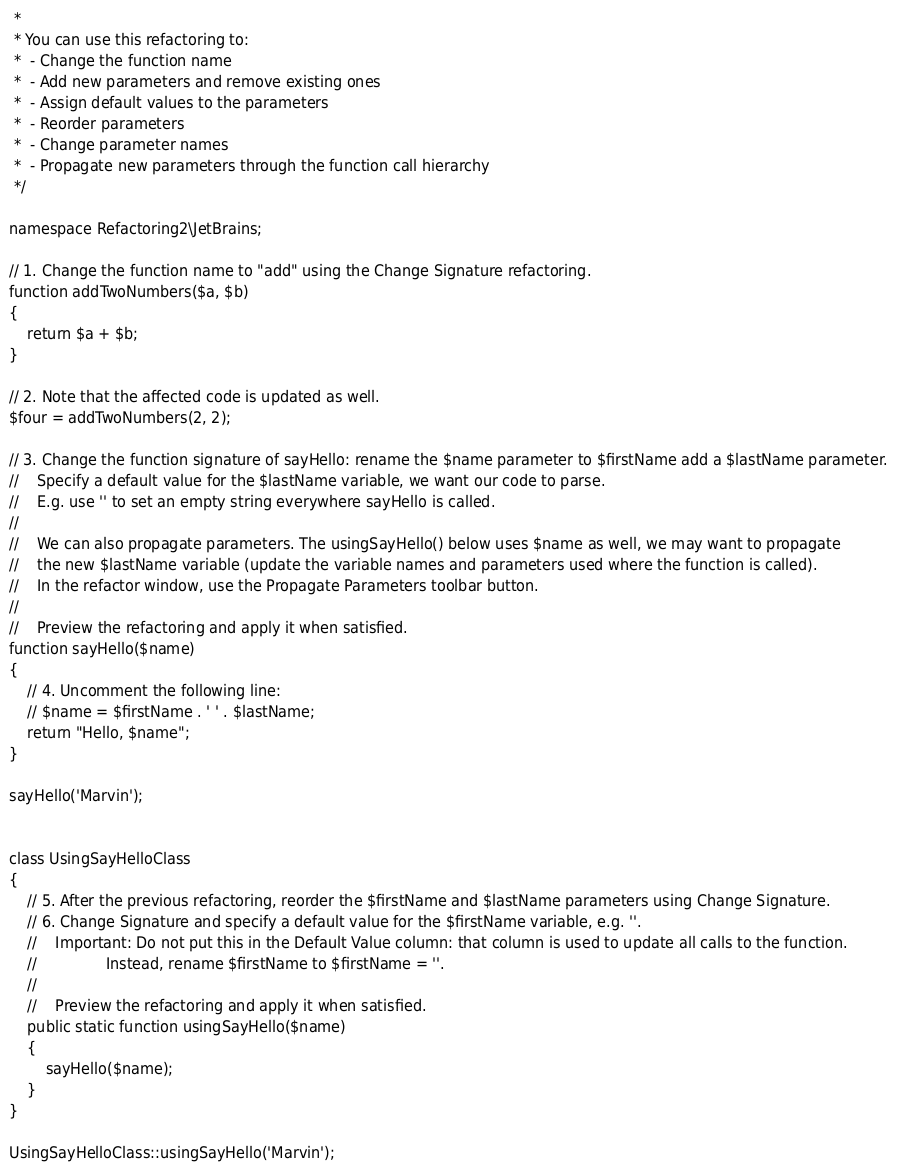Convert code to text. <code><loc_0><loc_0><loc_500><loc_500><_PHP_> *
 * You can use this refactoring to:
 *  - Change the function name
 *  - Add new parameters and remove existing ones
 *  - Assign default values to the parameters
 *  - Reorder parameters
 *  - Change parameter names
 *  - Propagate new parameters through the function call hierarchy
 */

namespace Refactoring2\JetBrains;

// 1. Change the function name to "add" using the Change Signature refactoring.
function addTwoNumbers($a, $b)
{
    return $a + $b;
}

// 2. Note that the affected code is updated as well.
$four = addTwoNumbers(2, 2);

// 3. Change the function signature of sayHello: rename the $name parameter to $firstName add a $lastName parameter.
//    Specify a default value for the $lastName variable, we want our code to parse.
//    E.g. use '' to set an empty string everywhere sayHello is called.
//
//    We can also propagate parameters. The usingSayHello() below uses $name as well, we may want to propagate
//    the new $lastName variable (update the variable names and parameters used where the function is called).
//    In the refactor window, use the Propagate Parameters toolbar button.
//
//    Preview the refactoring and apply it when satisfied.
function sayHello($name)
{
    // 4. Uncomment the following line:
    // $name = $firstName . ' ' . $lastName;
    return "Hello, $name";
}

sayHello('Marvin');


class UsingSayHelloClass
{
    // 5. After the previous refactoring, reorder the $firstName and $lastName parameters using Change Signature.
    // 6. Change Signature and specify a default value for the $firstName variable, e.g. ''.
    //    Important: Do not put this in the Default Value column: that column is used to update all calls to the function.
    //               Instead, rename $firstName to $firstName = ''.
    //
    //    Preview the refactoring and apply it when satisfied.
    public static function usingSayHello($name)
    {
        sayHello($name);
    }
}

UsingSayHelloClass::usingSayHello('Marvin');
</code> 